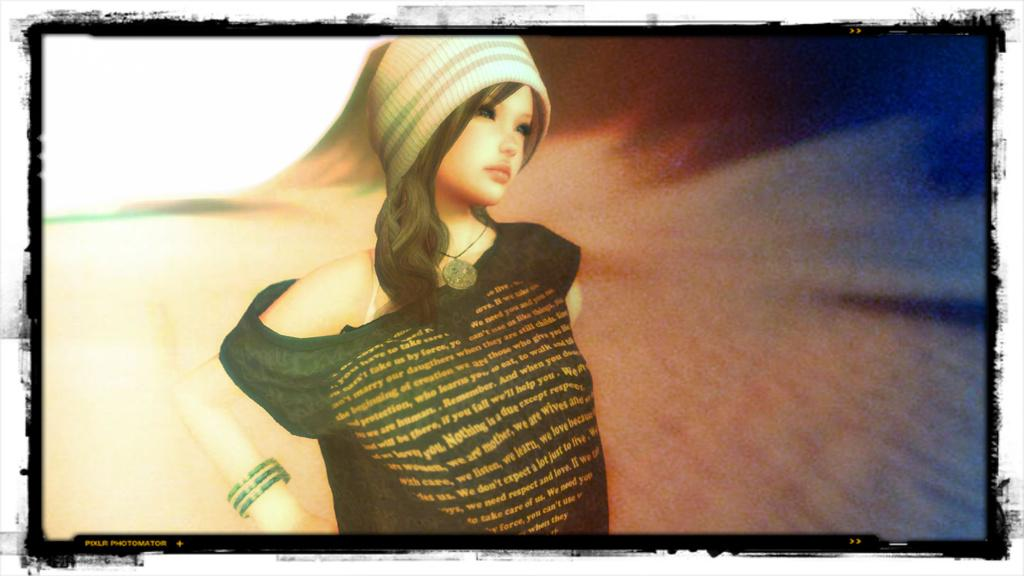What type of image is being described? The image is animated. Can you describe the main character in the image? There is a girl in the image. What is the girl wearing on her upper body? The girl is wearing a t-shirt. What is the girl wearing on her head? The girl is wearing a cap on her head. In which direction is the girl looking? The girl is looking to the right side. How would you describe the background of the image? The background of the image is blurred. What is the girl's income in the image? There is no information about the girl's income in the image. Can you see any visible injuries on the girl's wrist in the image? There is no mention of any injuries or the girl's wrist in the image. 